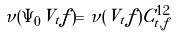Convert formula to latex. <formula><loc_0><loc_0><loc_500><loc_500>\nu ( \Psi _ { 0 } V _ { t } f ) = \nu ( V _ { t } f ) C ^ { 1 2 } _ { t , f }</formula> 